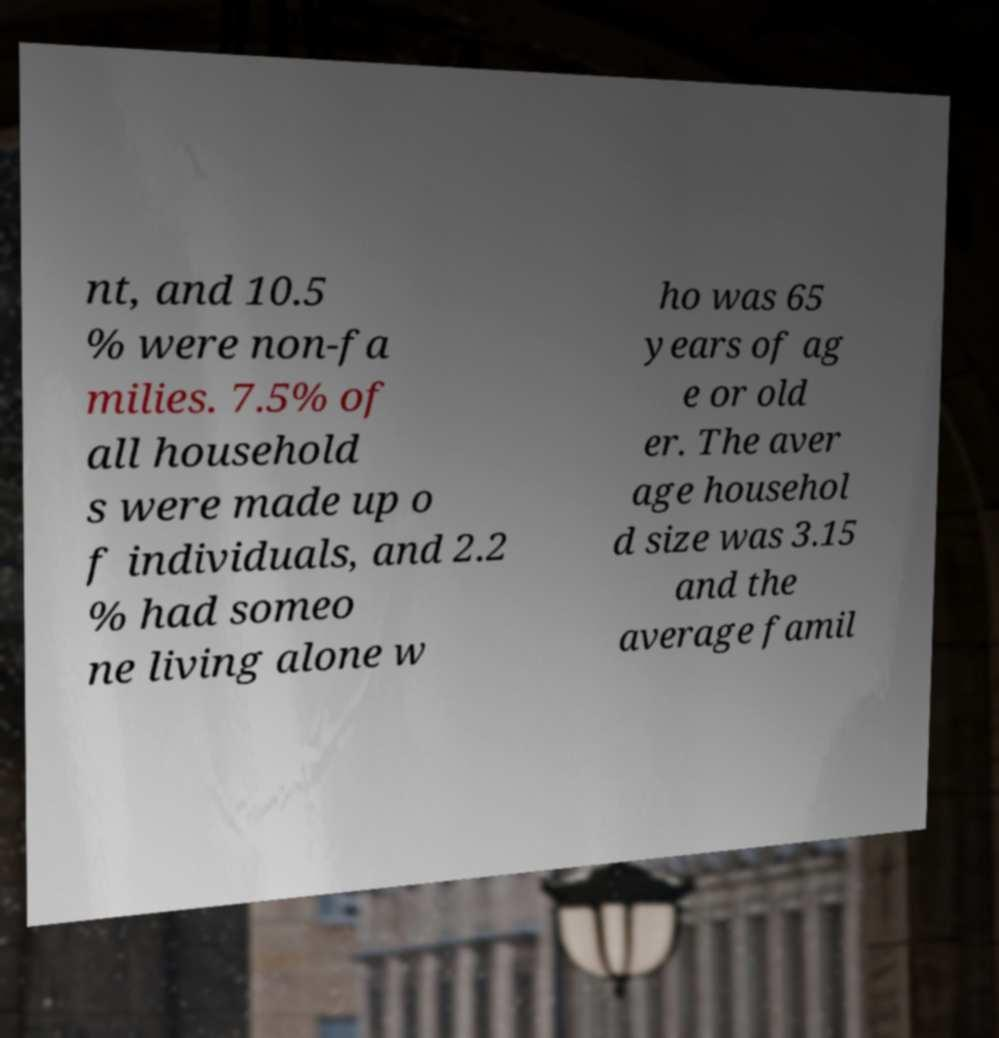There's text embedded in this image that I need extracted. Can you transcribe it verbatim? nt, and 10.5 % were non-fa milies. 7.5% of all household s were made up o f individuals, and 2.2 % had someo ne living alone w ho was 65 years of ag e or old er. The aver age househol d size was 3.15 and the average famil 